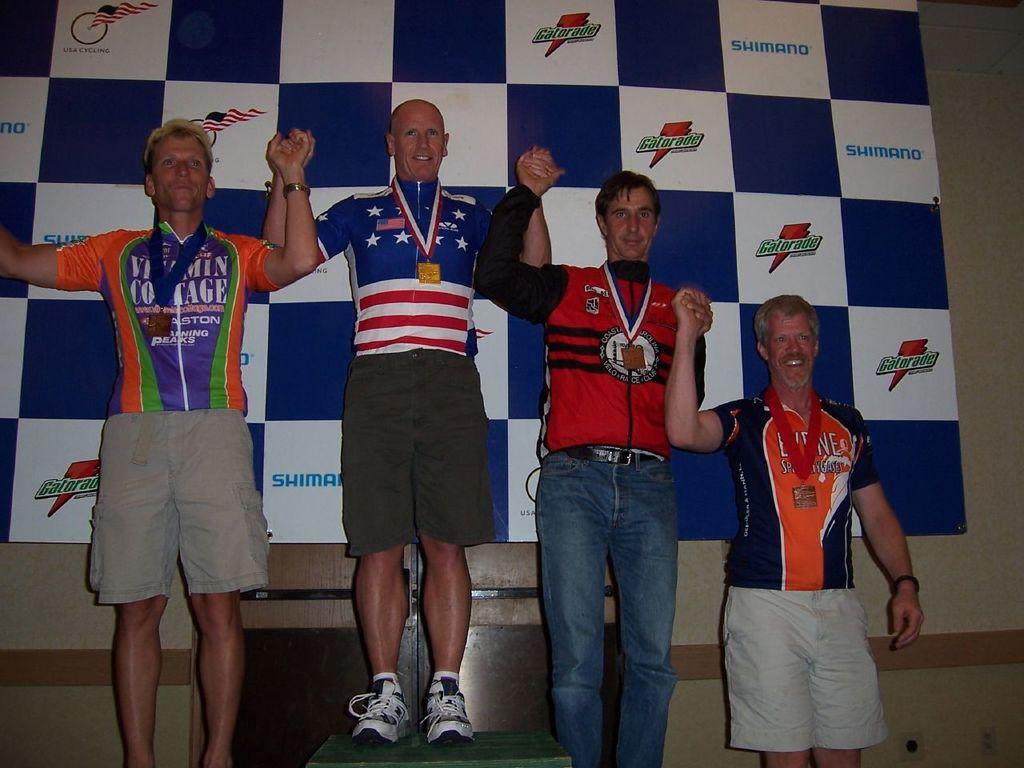What drink company is on the back board?
Ensure brevity in your answer.  Gatorade. 